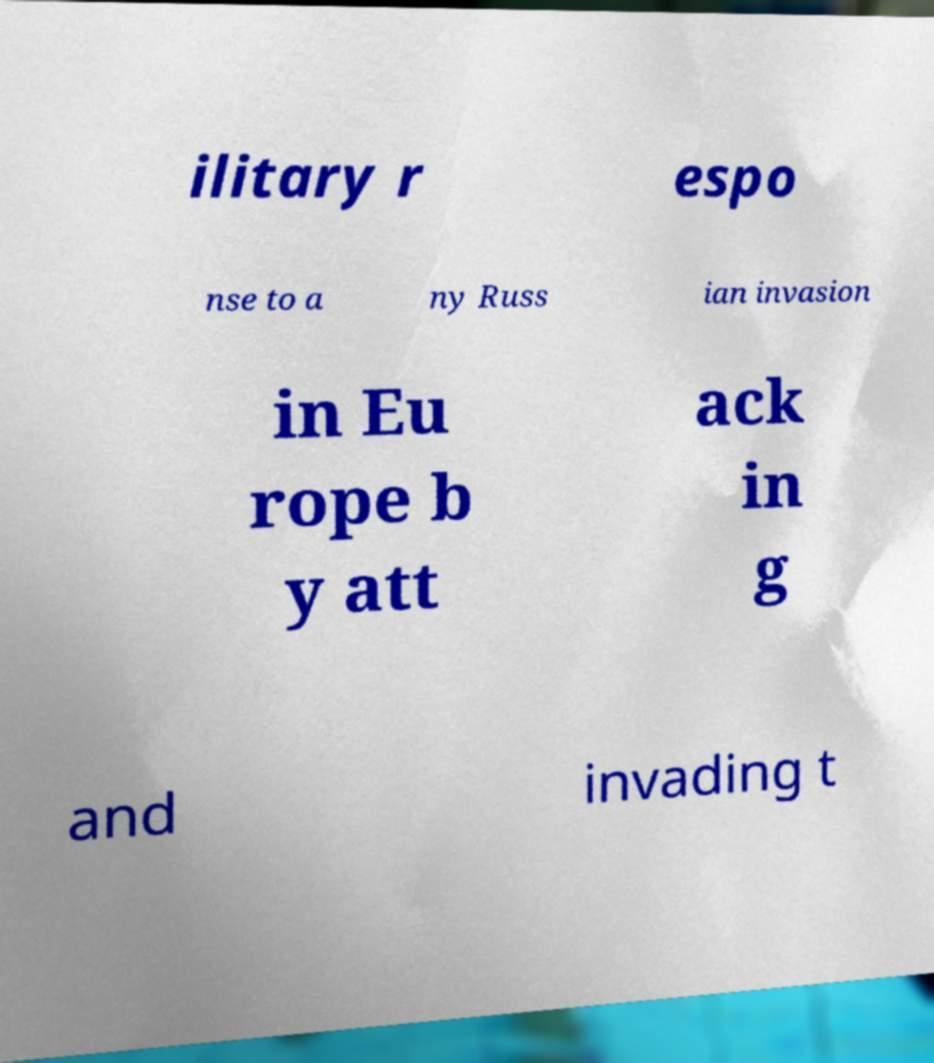There's text embedded in this image that I need extracted. Can you transcribe it verbatim? ilitary r espo nse to a ny Russ ian invasion in Eu rope b y att ack in g and invading t 